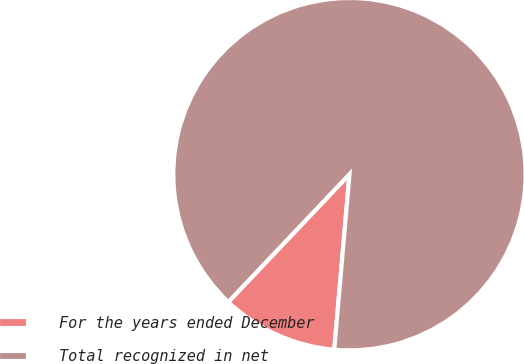Convert chart. <chart><loc_0><loc_0><loc_500><loc_500><pie_chart><fcel>For the years ended December<fcel>Total recognized in net<nl><fcel>10.7%<fcel>89.3%<nl></chart> 